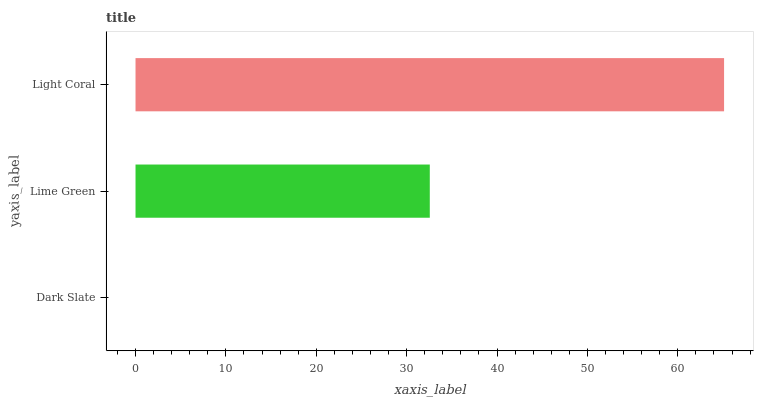Is Dark Slate the minimum?
Answer yes or no. Yes. Is Light Coral the maximum?
Answer yes or no. Yes. Is Lime Green the minimum?
Answer yes or no. No. Is Lime Green the maximum?
Answer yes or no. No. Is Lime Green greater than Dark Slate?
Answer yes or no. Yes. Is Dark Slate less than Lime Green?
Answer yes or no. Yes. Is Dark Slate greater than Lime Green?
Answer yes or no. No. Is Lime Green less than Dark Slate?
Answer yes or no. No. Is Lime Green the high median?
Answer yes or no. Yes. Is Lime Green the low median?
Answer yes or no. Yes. Is Light Coral the high median?
Answer yes or no. No. Is Light Coral the low median?
Answer yes or no. No. 